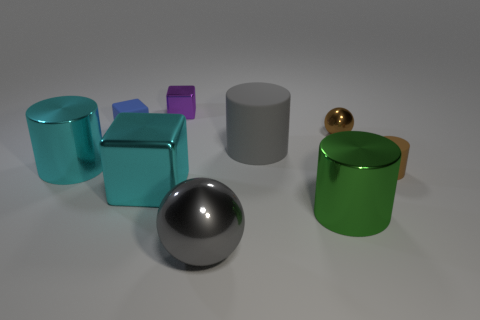What materials do you think the objects in the image are made of? The objects in the image seem to have various textures suggesting different materials. The shiny cylinder and sphere likely represent objects made of polished metals due to their reflective surfaces. The cube-like objects appear to have a matte finish, possibly made from plastic or painted wood. 